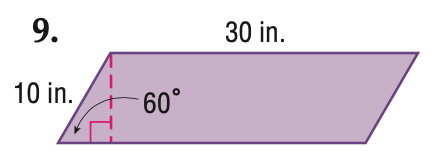Question: Find the area of the parallelogram. Round to the nearest tenth if necessary.
Choices:
A. 150
B. 259.9
C. 300
D. 519.6
Answer with the letter. Answer: B Question: Find the perimeter of the parallelogram. Round to the nearest tenth if necessary.
Choices:
A. 60
B. 80
C. 100
D. 120
Answer with the letter. Answer: B 